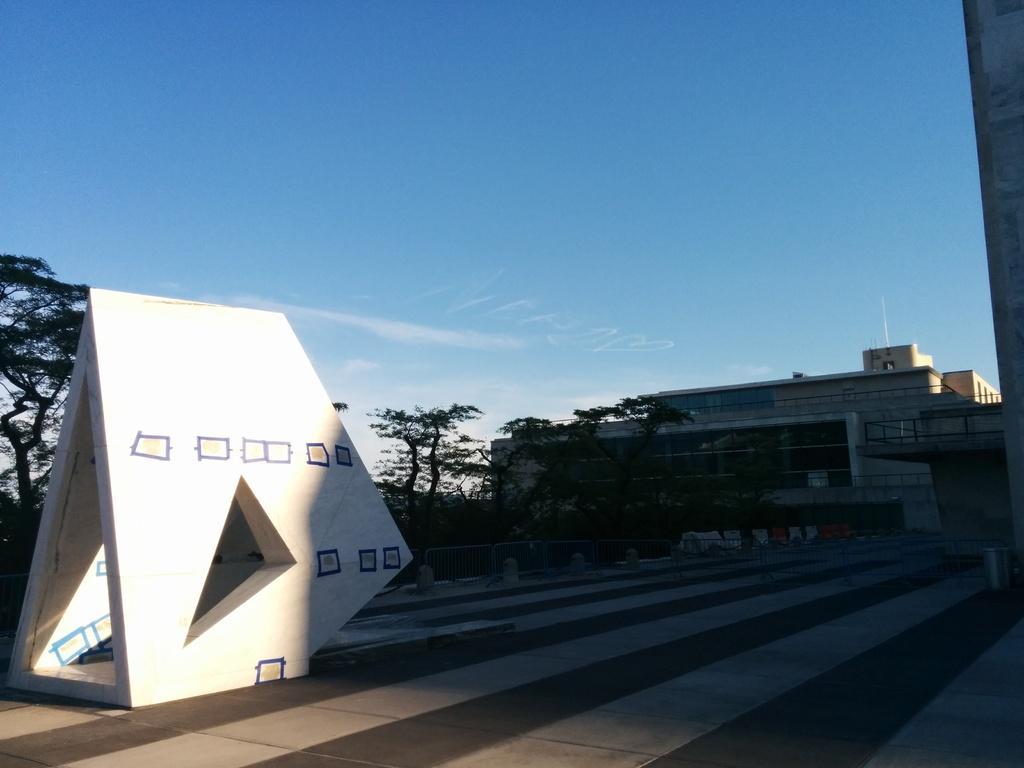Please provide a concise description of this image. In this image we can see trees, sculpture, building, sky and clouds. 